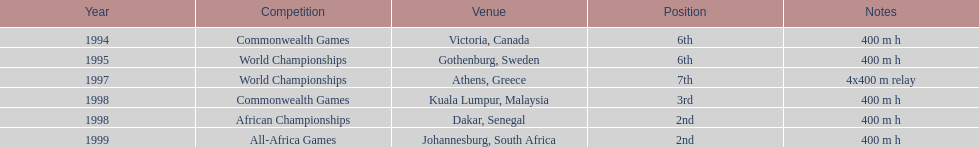Can you give me this table as a dict? {'header': ['Year', 'Competition', 'Venue', 'Position', 'Notes'], 'rows': [['1994', 'Commonwealth Games', 'Victoria, Canada', '6th', '400 m h'], ['1995', 'World Championships', 'Gothenburg, Sweden', '6th', '400 m h'], ['1997', 'World Championships', 'Athens, Greece', '7th', '4x400 m relay'], ['1998', 'Commonwealth Games', 'Kuala Lumpur, Malaysia', '3rd', '400 m h'], ['1998', 'African Championships', 'Dakar, Senegal', '2nd', '400 m h'], ['1999', 'All-Africa Games', 'Johannesburg, South Africa', '2nd', '400 m h']]} How many titles does ken harden have to his name? 6. 